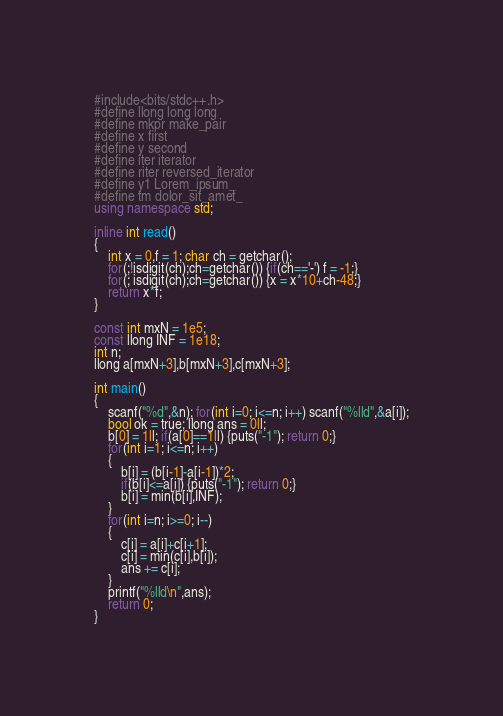Convert code to text. <code><loc_0><loc_0><loc_500><loc_500><_C++_>#include<bits/stdc++.h>
#define llong long long
#define mkpr make_pair
#define x first
#define y second
#define iter iterator
#define riter reversed_iterator
#define y1 Lorem_ipsum_
#define tm dolor_sit_amet_
using namespace std;

inline int read()
{
	int x = 0,f = 1; char ch = getchar();
	for(;!isdigit(ch);ch=getchar()) {if(ch=='-') f = -1;}
	for(; isdigit(ch);ch=getchar()) {x = x*10+ch-48;}
	return x*f;
}

const int mxN = 1e5;
const llong INF = 1e18;
int n;
llong a[mxN+3],b[mxN+3],c[mxN+3];

int main()
{
	scanf("%d",&n); for(int i=0; i<=n; i++) scanf("%lld",&a[i]);
	bool ok = true; llong ans = 0ll;
	b[0] = 1ll; if(a[0]==1ll) {puts("-1"); return 0;}
	for(int i=1; i<=n; i++)
	{
		b[i] = (b[i-1]-a[i-1])*2;
		if(b[i]<=a[i]) {puts("-1"); return 0;}
		b[i] = min(b[i],INF);
	}
	for(int i=n; i>=0; i--)
	{
		c[i] = a[i]+c[i+1];
		c[i] = min(c[i],b[i]);
		ans += c[i];
	}
	printf("%lld\n",ans);
	return 0;
}</code> 